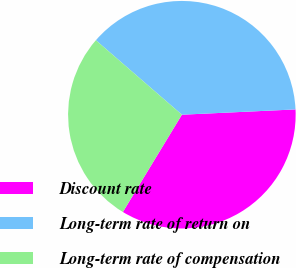<chart> <loc_0><loc_0><loc_500><loc_500><pie_chart><fcel>Discount rate<fcel>Long-term rate of return on<fcel>Long-term rate of compensation<nl><fcel>34.42%<fcel>37.9%<fcel>27.68%<nl></chart> 